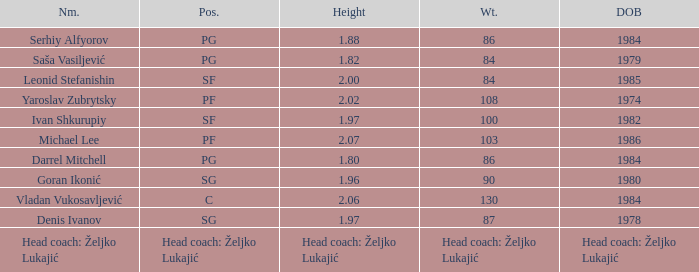What is the position of the player born in 1984 with a height of 1.80m? PG. 